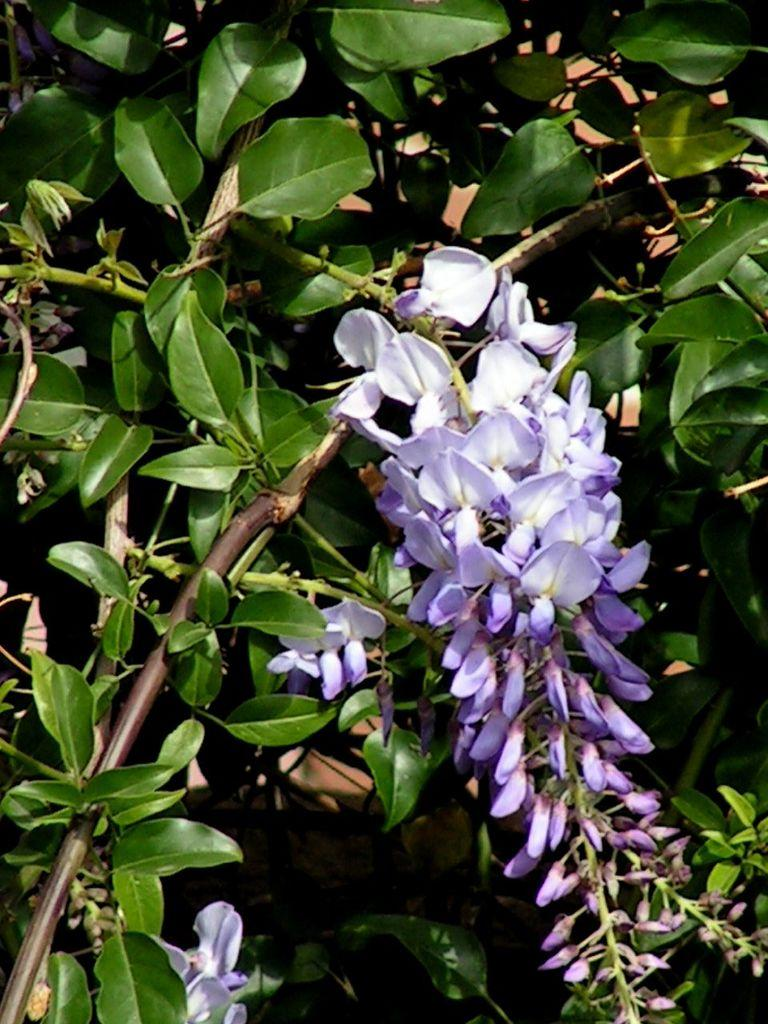What type of living organism is in the image? There is a plant in the image. What color are the flowers on the plant? The flowers on the plant are purple. Can you describe any other features of the plant? There is a bud on the plant. What type of pleasure can be seen in the image? There is no pleasure present in the image; it features a plant with purple flowers and a bud. Can you describe the art style used in the image? The image does not depict any art or artistic style; it is a photograph of a plant. 